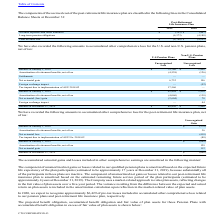According to Cts Corporation's financial document, What was the Accrued expenses and other liabilities in 2018? According to the financial document, (407) (in thousands). The relevant text states: "Accrued expenses and other liabilities $ (393) $ (407)..." Also, What was the total accrued cost in 2019? According to the financial document, (4,766) (in thousands). The relevant text states: "Total accrued cost $ (4,766) $ (4,595)..." Also, What were the Long-term pension obligations in 2018? According to the financial document, (4,188) (in thousands). The relevant text states: "Long-term pension obligations (4,373) (4,188)..." Also, can you calculate: What was the change in the Accrued expenses and other liabilities between 2018 and 2019? Based on the calculation: -393-(-407), the result is 14 (in thousands). This is based on the information: "Accrued expenses and other liabilities $ (393) $ (407) Accrued expenses and other liabilities $ (393) $ (407)..." The key data points involved are: 393, 407. Also, can you calculate: What was the change in the Long-term pension obligations between 2018 and 2019? Based on the calculation: -4,373-(-4,188), the result is -185 (in thousands). This is based on the information: "Long-term pension obligations (4,373) (4,188) Long-term pension obligations (4,373) (4,188)..." The key data points involved are: 4,188, 4,373. Also, can you calculate: What was the percentage change in the total accrued cost between 2018 and 2019? To answer this question, I need to perform calculations using the financial data. The calculation is: (-4,766-(-4,595))/-4,595, which equals 3.72 (percentage). This is based on the information: "Total accrued cost $ (4,766) $ (4,595) Total accrued cost $ (4,766) $ (4,595)..." The key data points involved are: 4,595, 4,766. 